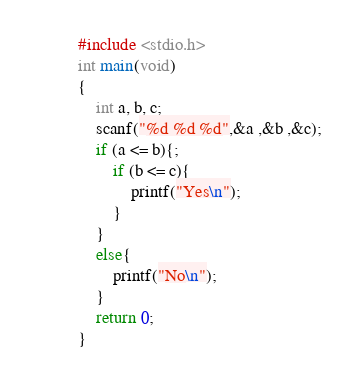Convert code to text. <code><loc_0><loc_0><loc_500><loc_500><_C_>#include <stdio.h>
int main(void)
{
	int a, b, c;
	scanf("%d %d %d",&a ,&b ,&c);
	if (a <= b){;
		if (b <= c){
			printf("Yes\n");
		}
	}
	else{
		printf("No\n");
	}
	return 0;
}</code> 